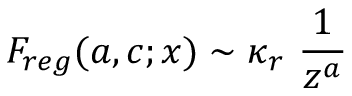Convert formula to latex. <formula><loc_0><loc_0><loc_500><loc_500>F _ { r e g } ( a , c ; x ) \sim \kappa _ { r } \ { \frac { 1 } { z ^ { a } } }</formula> 